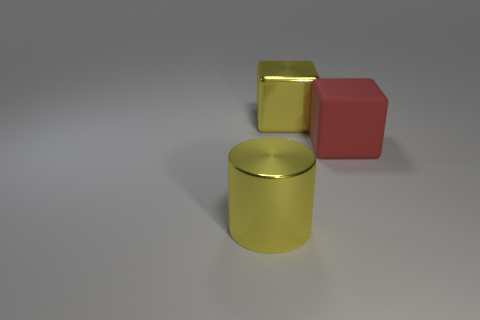Is there anything else that has the same color as the metal cylinder?
Give a very brief answer. Yes. There is a object that is in front of the red rubber thing; what size is it?
Your response must be concise. Large. Does the large matte block have the same color as the shiny thing that is to the left of the big metal block?
Your response must be concise. No. What number of other things are there of the same material as the large red cube
Provide a short and direct response. 0. Is the number of tiny green metal objects greater than the number of yellow cylinders?
Make the answer very short. No. There is a shiny thing behind the cylinder; is its color the same as the metallic cylinder?
Offer a terse response. Yes. What is the color of the big cylinder?
Ensure brevity in your answer.  Yellow. Is there a big red block that is left of the metallic object behind the rubber block?
Offer a terse response. No. There is a large yellow shiny thing that is in front of the large yellow metallic object that is behind the large cylinder; what shape is it?
Keep it short and to the point. Cylinder. Is the number of red cubes less than the number of large gray cylinders?
Make the answer very short. No. 